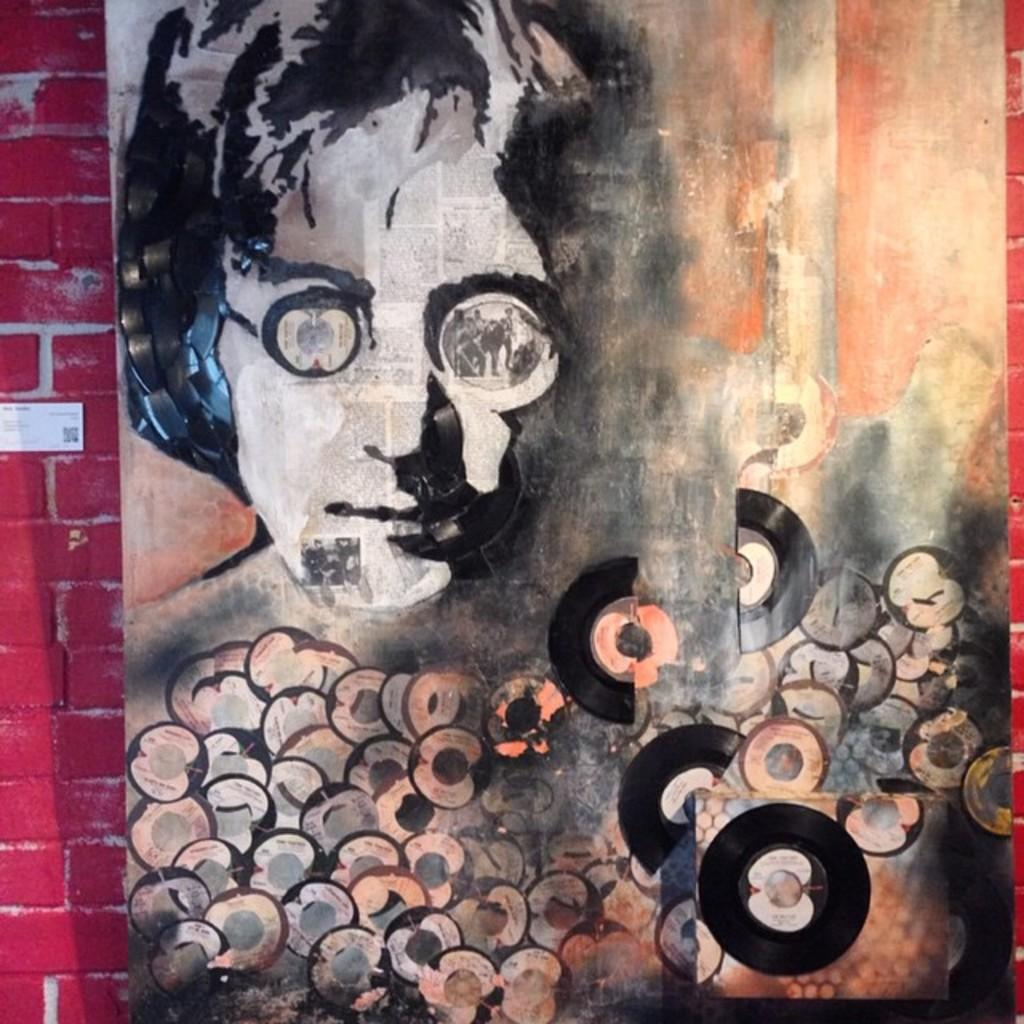What is the main subject of the image? There is a painting in the image. What does the painting depict? The painting depicts a person's face on a wall. What is the reason for the cast on the person's face in the painting? There is no cast visible on the person's face in the painting. Is it raining in the image? The provided facts do not mention anything about rain, so we cannot determine if it is raining in the image. 